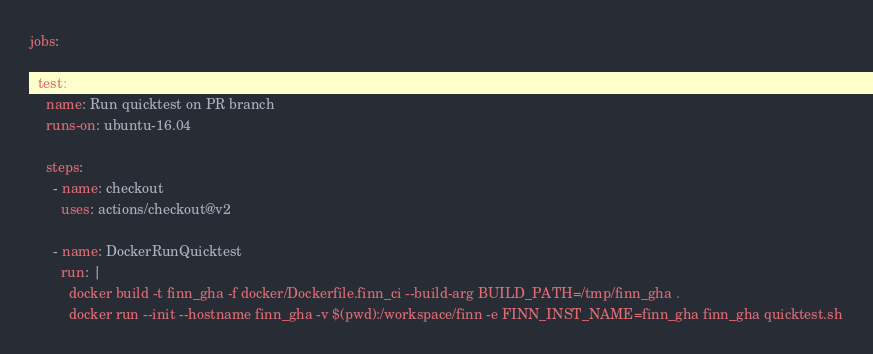Convert code to text. <code><loc_0><loc_0><loc_500><loc_500><_YAML_>

jobs:

  test:
    name: Run quicktest on PR branch
    runs-on: ubuntu-16.04

    steps:
      - name: checkout
        uses: actions/checkout@v2

      - name: DockerRunQuicktest
        run: |
          docker build -t finn_gha -f docker/Dockerfile.finn_ci --build-arg BUILD_PATH=/tmp/finn_gha .
          docker run --init --hostname finn_gha -v $(pwd):/workspace/finn -e FINN_INST_NAME=finn_gha finn_gha quicktest.sh
</code> 